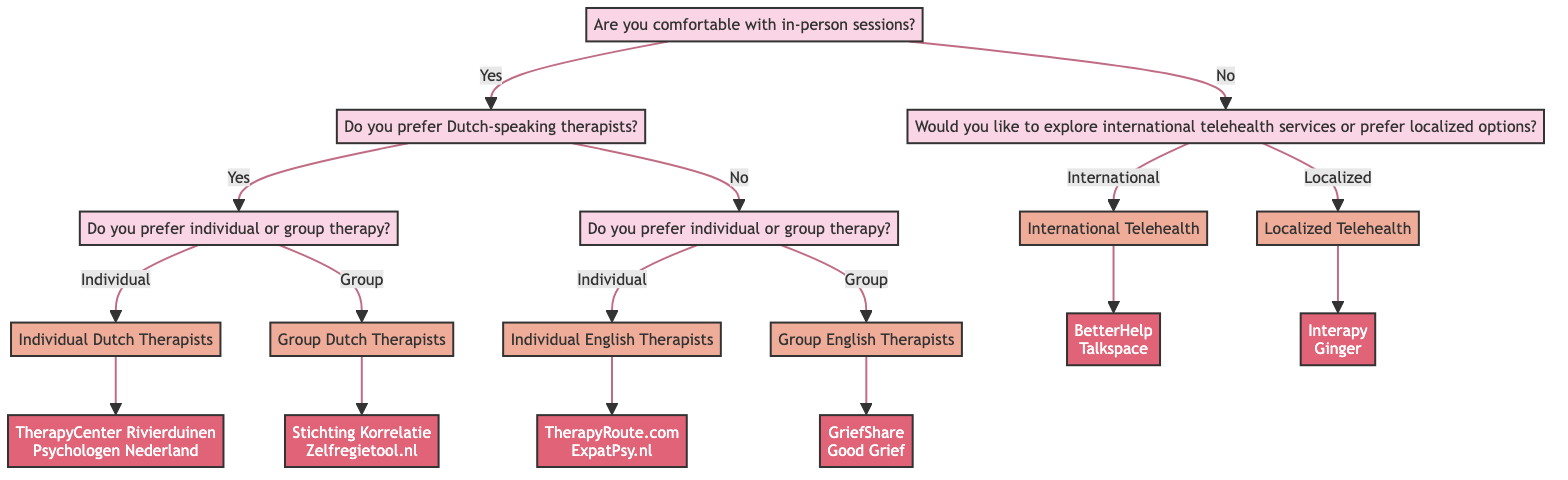Are there more options for Dutch-speaking therapists compared to English-speaking therapists? In the diagram, if we follow the branches for Dutch-speaking therapists, we find two endpoints: "TherapyCenter Rivierduinen" and "Psychologen Nederland." Conversely, the English-speaking branch also has two endpoints: "TherapyRoute.com" and "ExpatPsy.nl." Thus, the number of options is equal between Dutch and English-speaking therapists.
Answer: No What is the first question asked in the decision tree? The initial question presented is about comfort with in-person sessions. This question leads to different branches in the decision-making process.
Answer: Are you comfortable with in-person sessions? How many potential therapy options are there if someone chooses localized telehealth? Following the localized telehealth branch, we find two options: "Interapy" and "Ginger." These options represent the therapies available for those choosing this route.
Answer: 2 If someone prefers individual English therapists, what services do they get? The branch for individual English therapists leads to two specific services: "TherapyRoute.com" and "ExpatPsy.nl." Therefore, these are the options available for this preference.
Answer: TherapyRoute.com, ExpatPsy.nl What do you need to answer after expressing a preference for in-person sessions? After confirming comfort with in-person sessions, the next question to be answered is about the preference for Dutch-speaking therapists, directing the flow towards various therapy options based on language preference.
Answer: Do you prefer Dutch-speaking therapists? What happens if someone is not comfortable with in-person sessions? If the individual expresses discomfort with in-person sessions, they will answer a question related to their preference for international telehealth services versus localized options. This determines the next set of potential therapy resources available.
Answer: Would you like to explore international telehealth services or prefer localized options? How many total therapist options are there if someone prefers group therapy in Dutch? For those who prefer group therapy among Dutch therapists, the diagram lists two options: "Stichting Korrelatie" and "Zelfregietool.nl." These two form the complete set of choices based on this specific preference.
Answer: 2 What type of questions follow the first one about in-person sessions? The question following the comfort level with in-person sessions focuses on language preferences (Dutch or English), leading to different branches based on these responses. This branching creates more specific therapy choices.
Answer: Do you prefer Dutch-speaking therapists? 